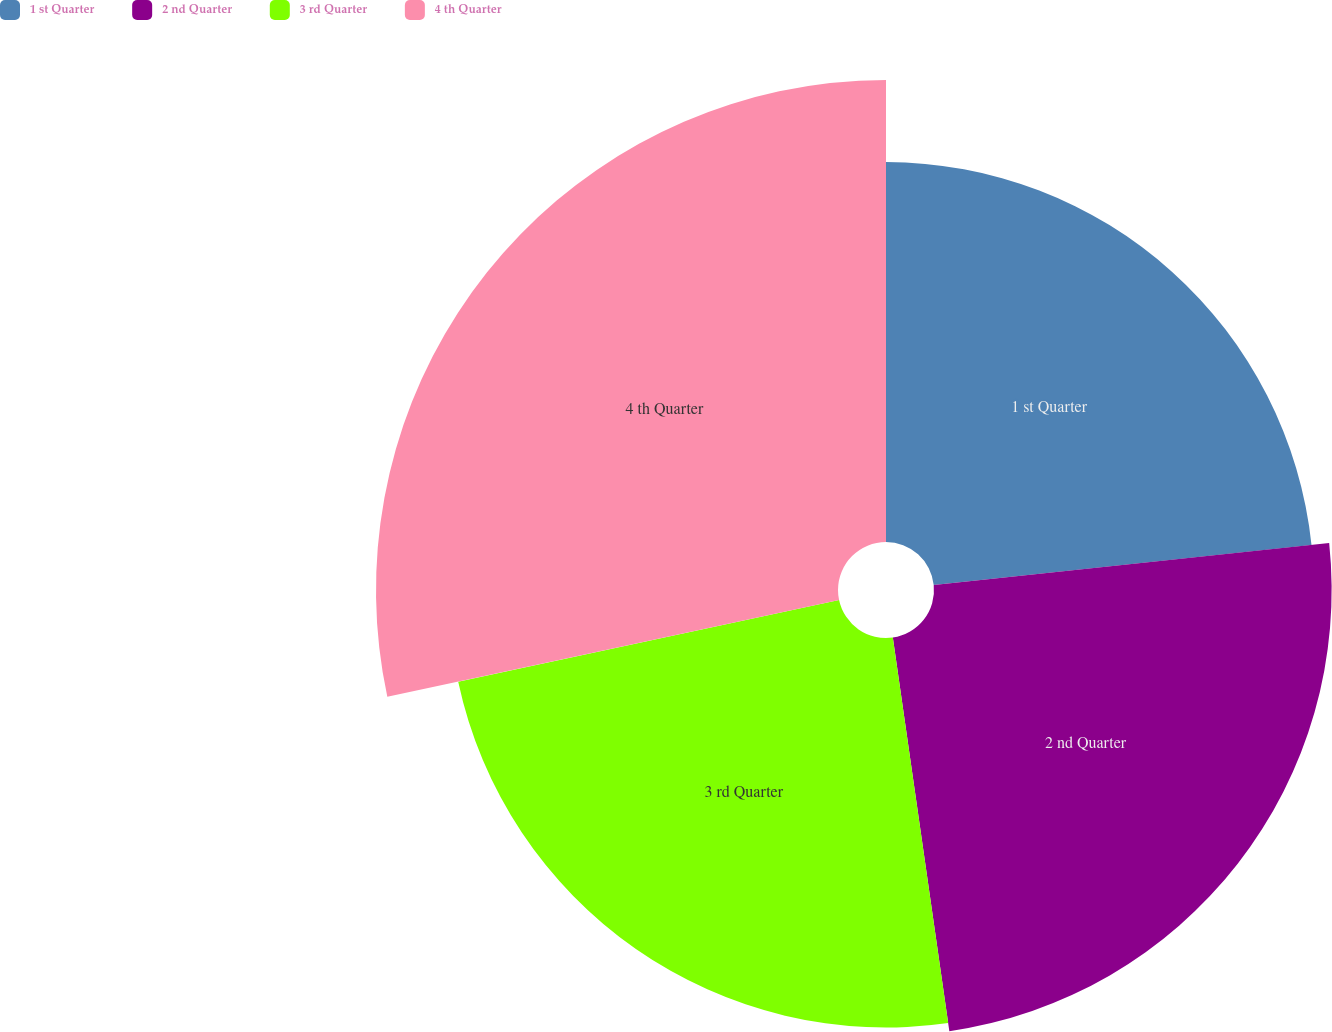Convert chart. <chart><loc_0><loc_0><loc_500><loc_500><pie_chart><fcel>1 st Quarter<fcel>2 nd Quarter<fcel>3 rd Quarter<fcel>4 th Quarter<nl><fcel>23.32%<fcel>24.41%<fcel>23.91%<fcel>28.36%<nl></chart> 